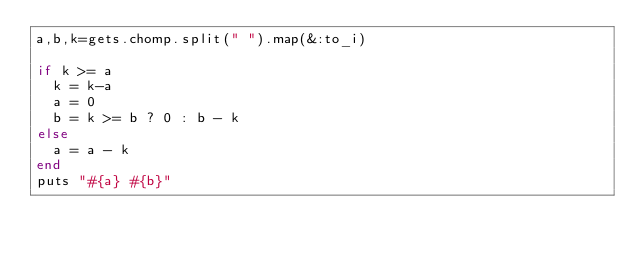Convert code to text. <code><loc_0><loc_0><loc_500><loc_500><_Ruby_>a,b,k=gets.chomp.split(" ").map(&:to_i)

if k >= a
  k = k-a
  a = 0
  b = k >= b ? 0 : b - k
else
  a = a - k
end
puts "#{a} #{b}"</code> 